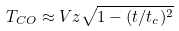<formula> <loc_0><loc_0><loc_500><loc_500>T _ { C O } \approx V z \sqrt { 1 - ( t / t _ { c } ) ^ { 2 } }</formula> 